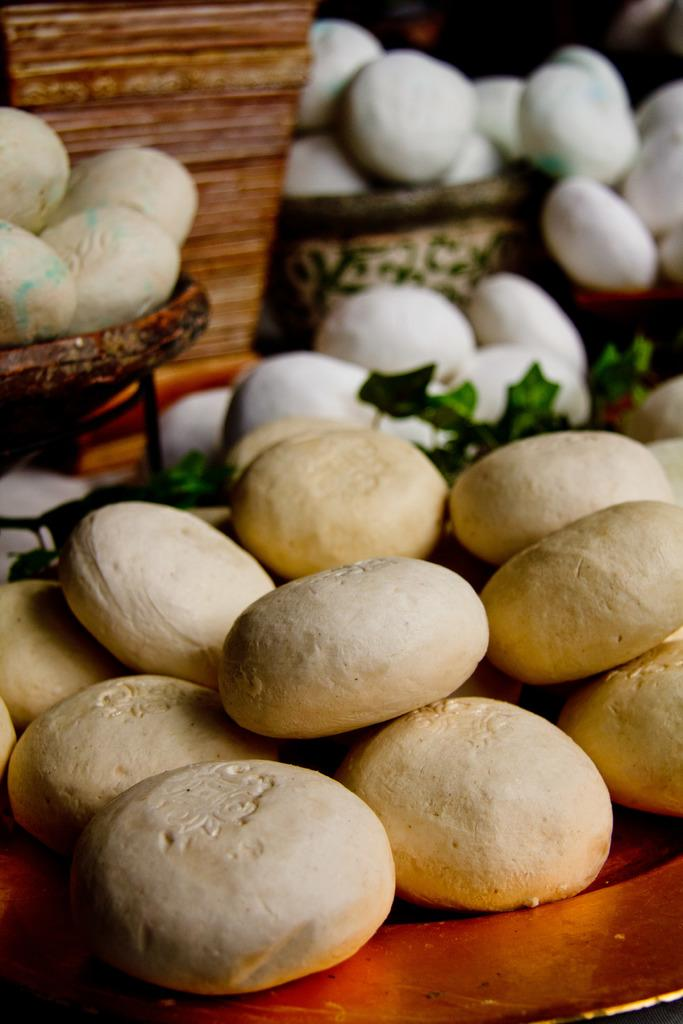What type of objects can be seen in the image? There are stones and containers in the image. Can you describe the stones in the image? The stones are the main objects visible in the image. What are the containers used for in the image? The purpose of the containers is not specified in the image, but they are present alongside the stones. What type of music can be heard playing in the background of the image? There is no music or audio present in the image, as it is a still image. 